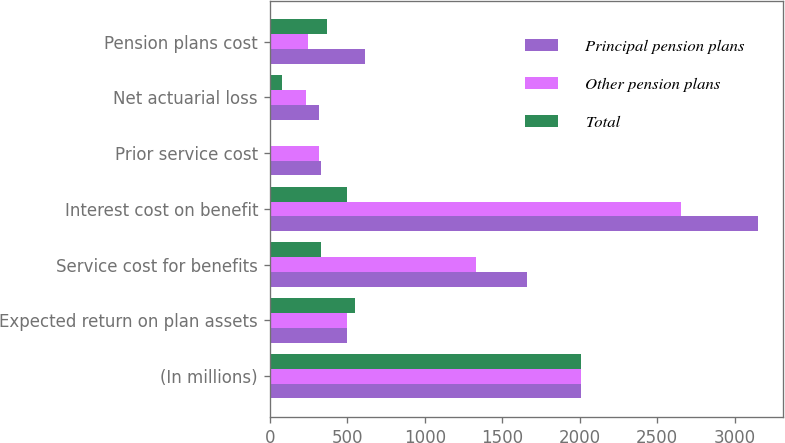<chart> <loc_0><loc_0><loc_500><loc_500><stacked_bar_chart><ecel><fcel>(In millions)<fcel>Expected return on plan assets<fcel>Service cost for benefits<fcel>Interest cost on benefit<fcel>Prior service cost<fcel>Net actuarial loss<fcel>Pension plans cost<nl><fcel>Principal pension plans<fcel>2008<fcel>499<fcel>1663<fcel>3152<fcel>332<fcel>316<fcel>613<nl><fcel>Other pension plans<fcel>2008<fcel>499<fcel>1331<fcel>2653<fcel>321<fcel>237<fcel>244<nl><fcel>Total<fcel>2008<fcel>552<fcel>332<fcel>499<fcel>11<fcel>79<fcel>369<nl></chart> 